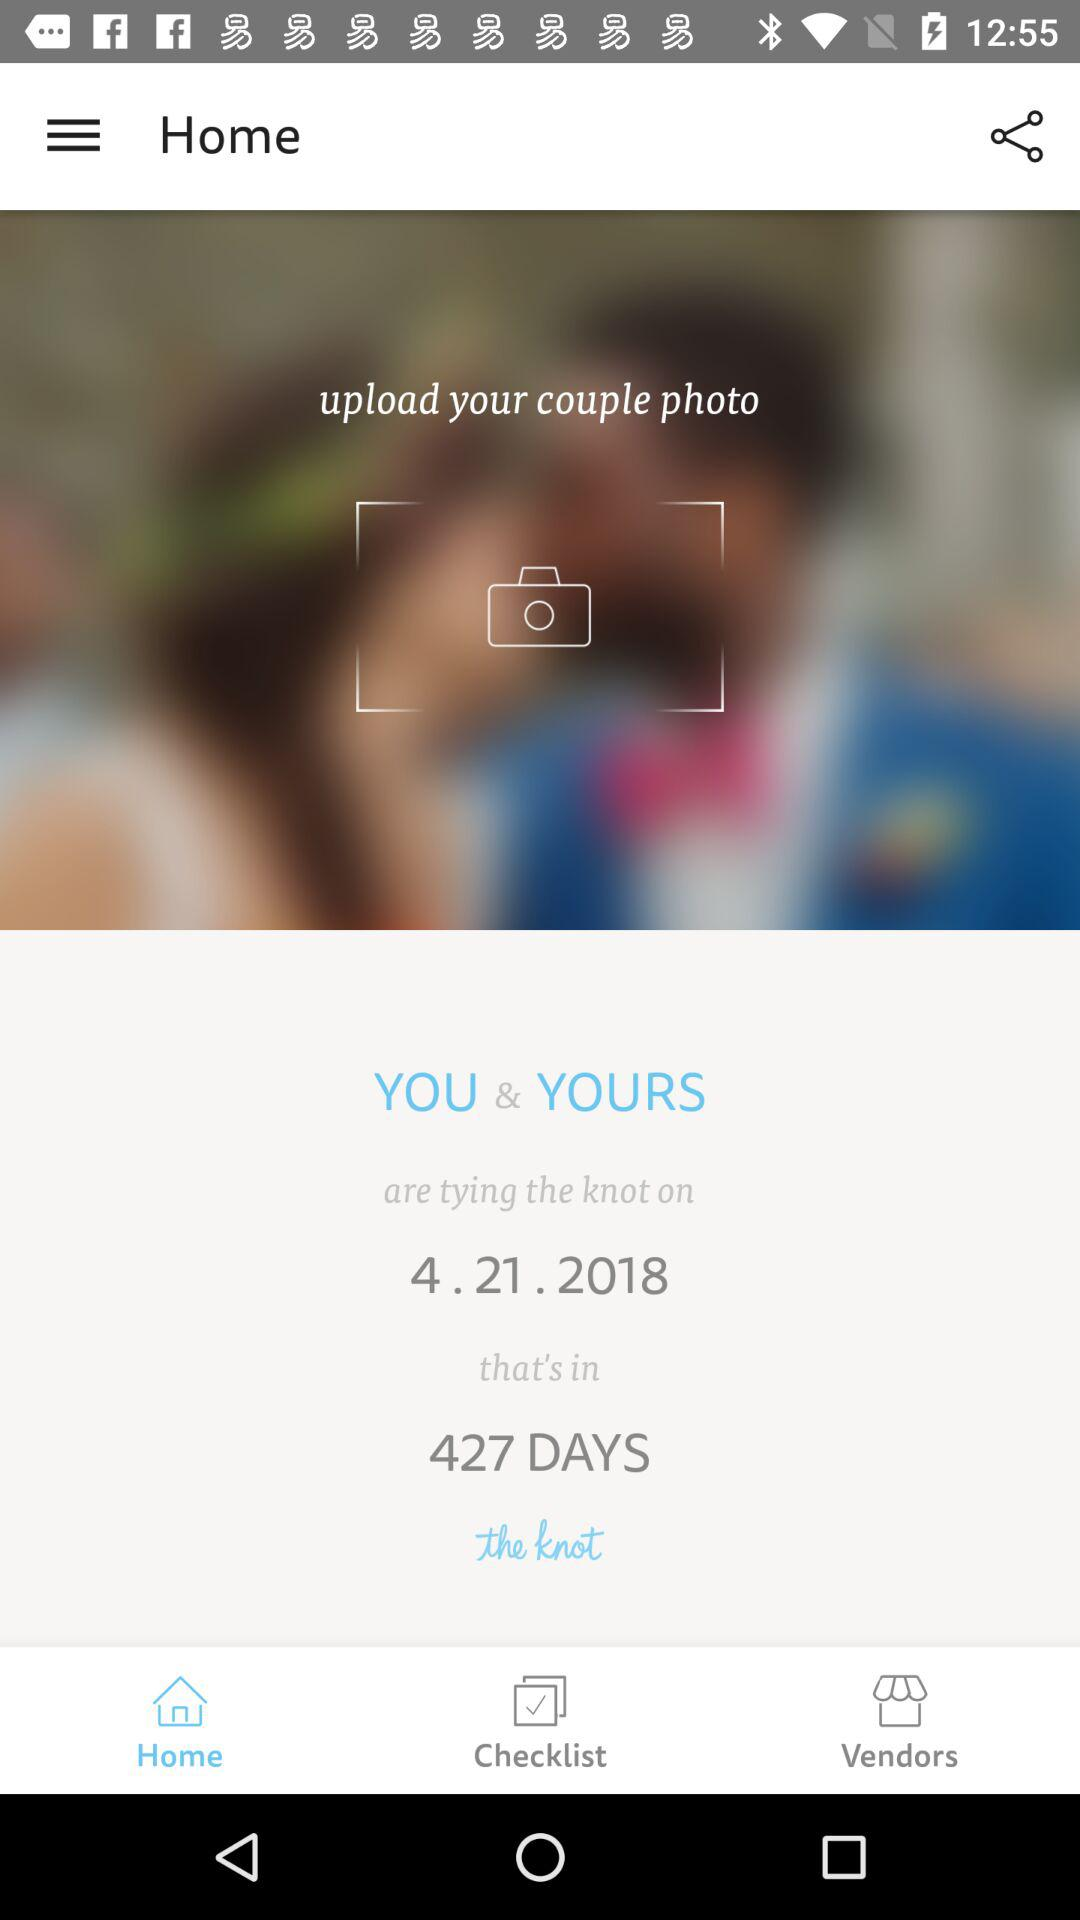What date is displayed? The displayed date is April 21, 2018. 